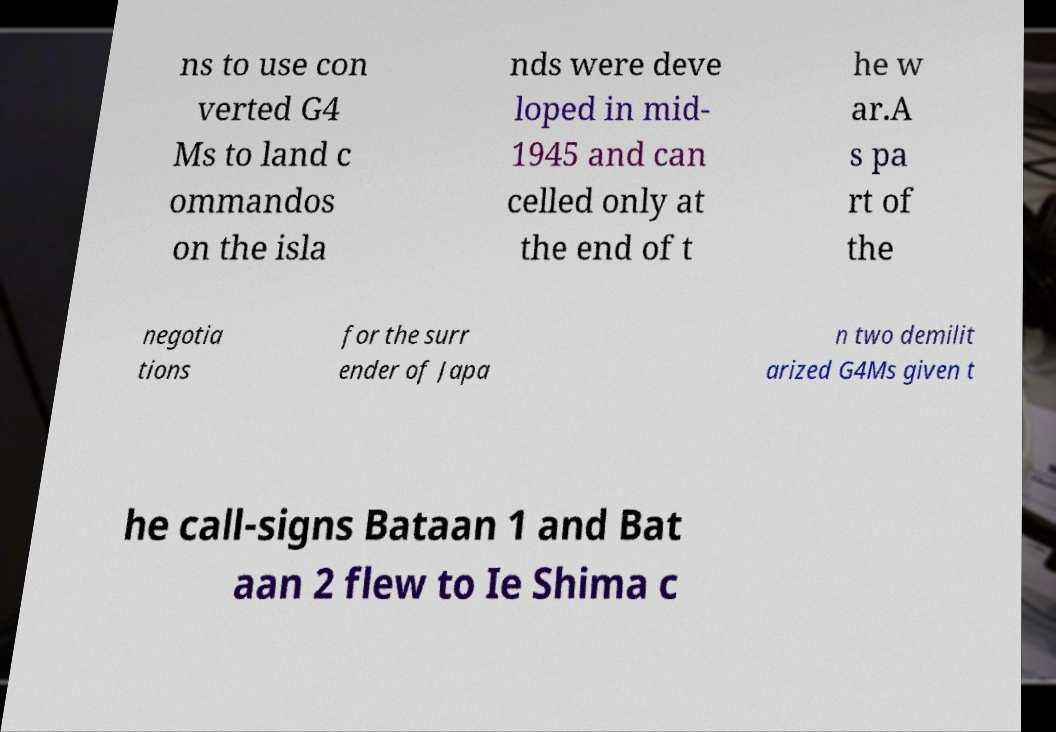For documentation purposes, I need the text within this image transcribed. Could you provide that? ns to use con verted G4 Ms to land c ommandos on the isla nds were deve loped in mid- 1945 and can celled only at the end of t he w ar.A s pa rt of the negotia tions for the surr ender of Japa n two demilit arized G4Ms given t he call-signs Bataan 1 and Bat aan 2 flew to Ie Shima c 